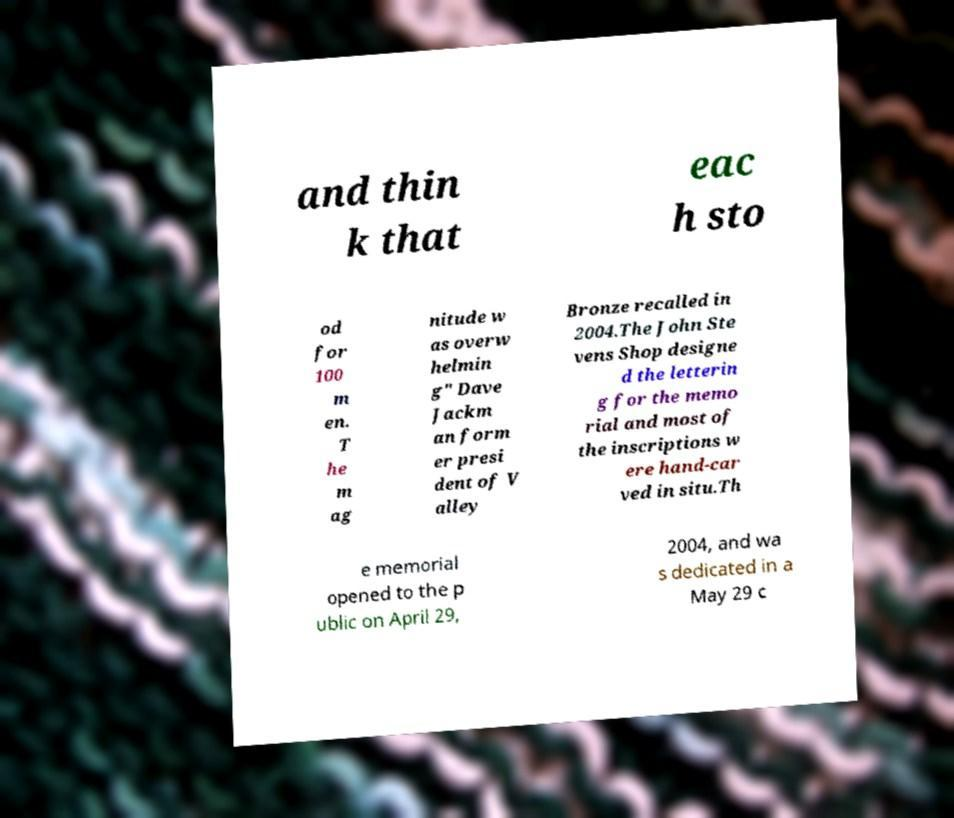For documentation purposes, I need the text within this image transcribed. Could you provide that? and thin k that eac h sto od for 100 m en. T he m ag nitude w as overw helmin g" Dave Jackm an form er presi dent of V alley Bronze recalled in 2004.The John Ste vens Shop designe d the letterin g for the memo rial and most of the inscriptions w ere hand-car ved in situ.Th e memorial opened to the p ublic on April 29, 2004, and wa s dedicated in a May 29 c 